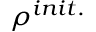Convert formula to latex. <formula><loc_0><loc_0><loc_500><loc_500>\rho ^ { i n i t . }</formula> 